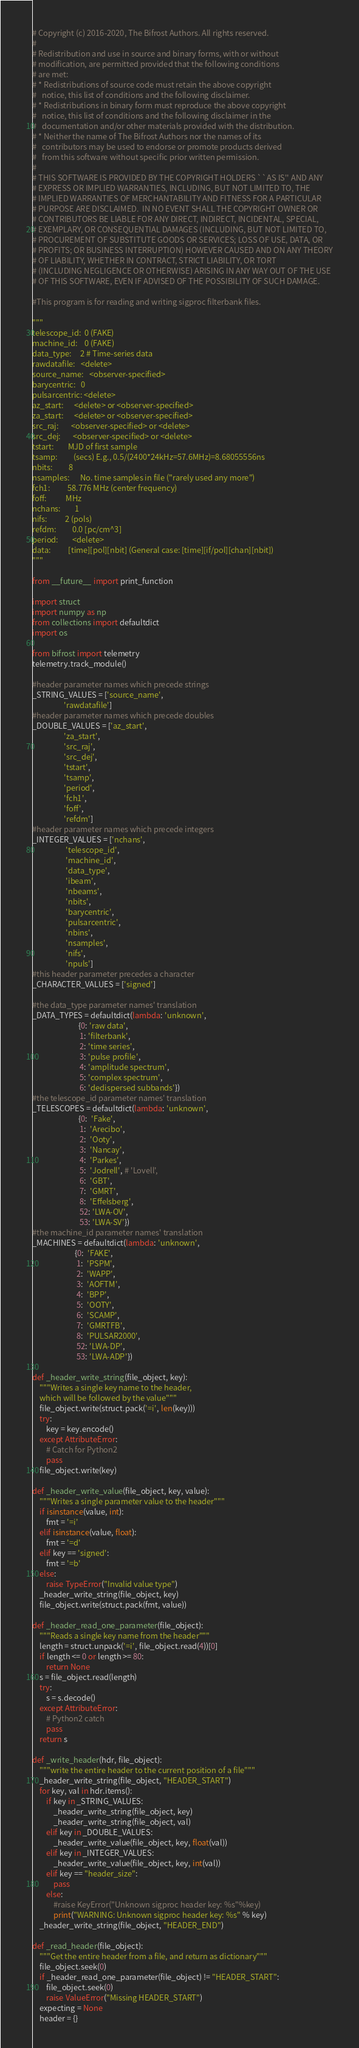Convert code to text. <code><loc_0><loc_0><loc_500><loc_500><_Python_>
# Copyright (c) 2016-2020, The Bifrost Authors. All rights reserved.
#
# Redistribution and use in source and binary forms, with or without
# modification, are permitted provided that the following conditions
# are met:
# * Redistributions of source code must retain the above copyright
#   notice, this list of conditions and the following disclaimer.
# * Redistributions in binary form must reproduce the above copyright
#   notice, this list of conditions and the following disclaimer in the
#   documentation and/or other materials provided with the distribution.
# * Neither the name of The Bifrost Authors nor the names of its
#   contributors may be used to endorse or promote products derived
#   from this software without specific prior written permission.
#
# THIS SOFTWARE IS PROVIDED BY THE COPYRIGHT HOLDERS ``AS IS'' AND ANY
# EXPRESS OR IMPLIED WARRANTIES, INCLUDING, BUT NOT LIMITED TO, THE
# IMPLIED WARRANTIES OF MERCHANTABILITY AND FITNESS FOR A PARTICULAR
# PURPOSE ARE DISCLAIMED.  IN NO EVENT SHALL THE COPYRIGHT OWNER OR
# CONTRIBUTORS BE LIABLE FOR ANY DIRECT, INDIRECT, INCIDENTAL, SPECIAL,
# EXEMPLARY, OR CONSEQUENTIAL DAMAGES (INCLUDING, BUT NOT LIMITED TO,
# PROCUREMENT OF SUBSTITUTE GOODS OR SERVICES; LOSS OF USE, DATA, OR
# PROFITS; OR BUSINESS INTERRUPTION) HOWEVER CAUSED AND ON ANY THEORY
# OF LIABILITY, WHETHER IN CONTRACT, STRICT LIABILITY, OR TORT
# (INCLUDING NEGLIGENCE OR OTHERWISE) ARISING IN ANY WAY OUT OF THE USE
# OF THIS SOFTWARE, EVEN IF ADVISED OF THE POSSIBILITY OF SUCH DAMAGE.

#This program is for reading and writing sigproc filterbank files.

"""
telescope_id:  0 (FAKE)
machine_id:    0 (FAKE)
data_type:     2 # Time-series data
rawdatafile:   <delete>
source_name:   <observer-specified>
barycentric:   0
pulsarcentric: <delete>
az_start:      <delete> or <observer-specified>
za_start:      <delete> or <observer-specified>
src_raj:       <observer-specified> or <delete>
src_dej:       <observer-specified> or <delete>
tstart:        MJD of first sample
tsamp:         (secs) E.g., 0.5/(2400*24kHz=57.6MHz)=8.68055556ns
nbits:         8
nsamples:      No. time samples in file ("rarely used any more")
fch1:          58.776 MHz (center frequency)
foff:           MHz
nchans:        1
nifs:          2 (pols)
refdm:         0.0 [pc/cm^3]
period:        <delete>
data:          [time][pol][nbit] (General case: [time][if/pol][chan][nbit])
"""

from __future__ import print_function

import struct
import numpy as np
from collections import defaultdict
import os

from bifrost import telemetry
telemetry.track_module()

#header parameter names which precede strings
_STRING_VALUES = ['source_name',
                  'rawdatafile']
#header parameter names which precede doubles
_DOUBLE_VALUES = ['az_start',
                  'za_start',
                  'src_raj',
                  'src_dej',
                  'tstart',
                  'tsamp',
                  'period',
                  'fch1',
                  'foff',
                  'refdm']
#header parameter names which precede integers
_INTEGER_VALUES = ['nchans',
                   'telescope_id',
                   'machine_id',
                   'data_type',
                   'ibeam',
                   'nbeams',
                   'nbits',
                   'barycentric',
                   'pulsarcentric',
                   'nbins',
                   'nsamples',
                   'nifs',
                   'npuls']
#this header parameter precedes a character
_CHARACTER_VALUES = ['signed']

#the data_type parameter names' translation
_DATA_TYPES = defaultdict(lambda: 'unknown',
                          {0: 'raw data',
                           1: 'filterbank',
                           2: 'time series',
                           3: 'pulse profile',
                           4: 'amplitude spectrum',
                           5: 'complex spectrum',
                           6: 'dedispersed subbands'})
#the telescope_id parameter names' translation
_TELESCOPES = defaultdict(lambda: 'unknown',
                          {0:  'Fake',
                           1:  'Arecibo',
                           2:  'Ooty',
                           3:  'Nancay',
                           4:  'Parkes',
                           5:  'Jodrell', # 'Lovell',
                           6:  'GBT',
                           7:  'GMRT',
                           8:  'Effelsberg',
                           52: 'LWA-OV',
                           53: 'LWA-SV'})
#the machine_id parameter names' translation
_MACHINES = defaultdict(lambda: 'unknown',
                        {0:  'FAKE',
                         1:  'PSPM',
                         2:  'WAPP',
                         3:  'AOFTM',
                         4:  'BPP',
                         5:  'OOTY',
                         6:  'SCAMP',
                         7:  'GMRTFB',
                         8:  'PULSAR2000',
                         52: 'LWA-DP',
                         53: 'LWA-ADP'})

def _header_write_string(file_object, key):
    """Writes a single key name to the header,
    which will be followed by the value"""
    file_object.write(struct.pack('=i', len(key)))
    try:
        key = key.encode()
    except AttributeError:
        # Catch for Python2
        pass
    file_object.write(key)

def _header_write_value(file_object, key, value):
    """Writes a single parameter value to the header"""
    if isinstance(value, int):
        fmt = '=i'
    elif isinstance(value, float):
        fmt = '=d'
    elif key == 'signed':
        fmt = '=b'
    else:
        raise TypeError("Invalid value type")
    _header_write_string(file_object, key)
    file_object.write(struct.pack(fmt, value))

def _header_read_one_parameter(file_object):
    """Reads a single key name from the header"""
    length = struct.unpack('=i', file_object.read(4))[0]
    if length <= 0 or length >= 80:
        return None
    s = file_object.read(length)
    try:
        s = s.decode()
    except AttributeError:
        # Python2 catch
        pass
    return s

def _write_header(hdr, file_object):
    """write the entire header to the current position of a file"""
    _header_write_string(file_object, "HEADER_START")
    for key, val in hdr.items():
        if key in _STRING_VALUES:
            _header_write_string(file_object, key)
            _header_write_string(file_object, val)
        elif key in _DOUBLE_VALUES:
            _header_write_value(file_object, key, float(val))
        elif key in _INTEGER_VALUES:
            _header_write_value(file_object, key, int(val))
        elif key == "header_size":
            pass
        else:
            #raise KeyError("Unknown sigproc header key: %s"%key)
            print("WARNING: Unknown sigproc header key: %s" % key)
    _header_write_string(file_object, "HEADER_END")

def _read_header(file_object):
    """Get the entire header from a file, and return as dictionary"""
    file_object.seek(0)
    if _header_read_one_parameter(file_object) != "HEADER_START":
        file_object.seek(0)
        raise ValueError("Missing HEADER_START")
    expecting = None
    header = {}</code> 